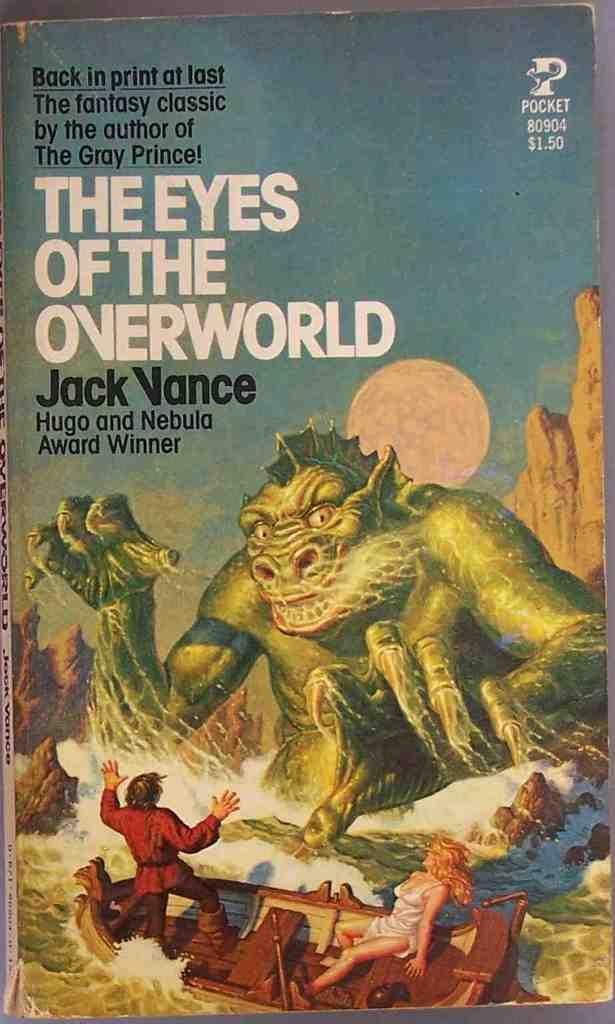<image>
Describe the image concisely. The title of this book is "The Eyes of the Overworld." 